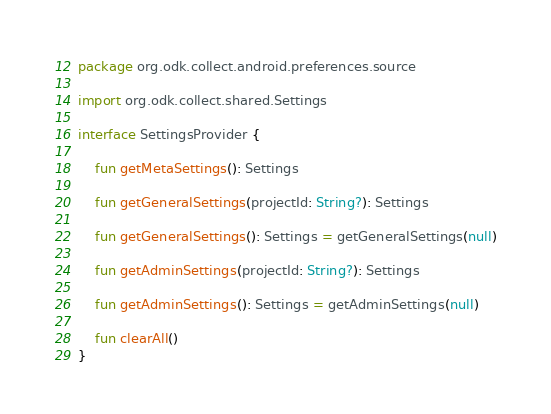<code> <loc_0><loc_0><loc_500><loc_500><_Kotlin_>package org.odk.collect.android.preferences.source

import org.odk.collect.shared.Settings

interface SettingsProvider {

    fun getMetaSettings(): Settings

    fun getGeneralSettings(projectId: String?): Settings

    fun getGeneralSettings(): Settings = getGeneralSettings(null)

    fun getAdminSettings(projectId: String?): Settings

    fun getAdminSettings(): Settings = getAdminSettings(null)

    fun clearAll()
}
</code> 